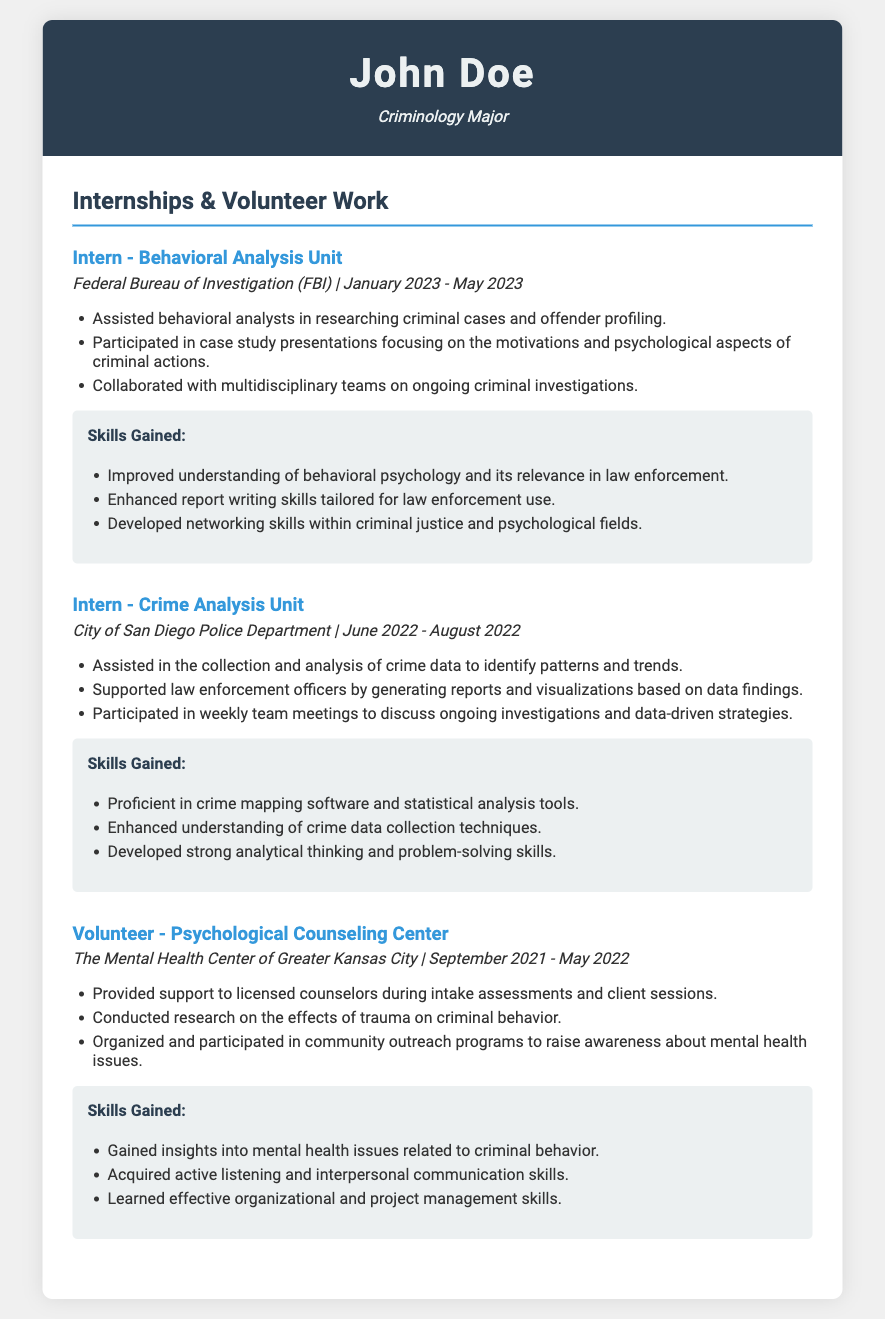What is the name of the first internship listed? The first internship listed is in the Behavioral Analysis Unit of the FBI, as detailed in the document.
Answer: Behavioral Analysis Unit What year did the intern work in the Crime Analysis Unit? The intern worked in the Crime Analysis Unit during the summer of 2022, which can be found in the internship details.
Answer: 2022 Who provided support during the intake assessments at the Psychological Counseling Center? The document mentions support provided to licensed counselors, making it clear who did the support work.
Answer: John Doe What type of software did the intern become proficient in? The document states the intern became proficient in crime mapping software as part of their training and experience.
Answer: Crime mapping software How long did the volunteer work at the Psychological Counseling Center last? The duration can be found by looking at the start and end dates provided for the volunteer position in the document.
Answer: 8 months What skill was enhanced through the internship at the Behavioral Analysis Unit? The document explicitly lists enhanced report writing skills as one of the skills gained during this internship.
Answer: Report writing skills What primary responsibility is mentioned for the Crime Analysis Unit intern? The document outlines assisting in the collection and analysis of crime data as the primary responsibility of this position.
Answer: Collection and analysis of crime data How many volunteer positions are listed in the document? Since the document lists only one volunteer position at the Psychological Counseling Center, it's a straightforward count.
Answer: 1 In which city was the police department located for the Crime Analysis Unit internship? The document specifies the City of San Diego as the location of the police department for this internship experience.
Answer: San Diego 